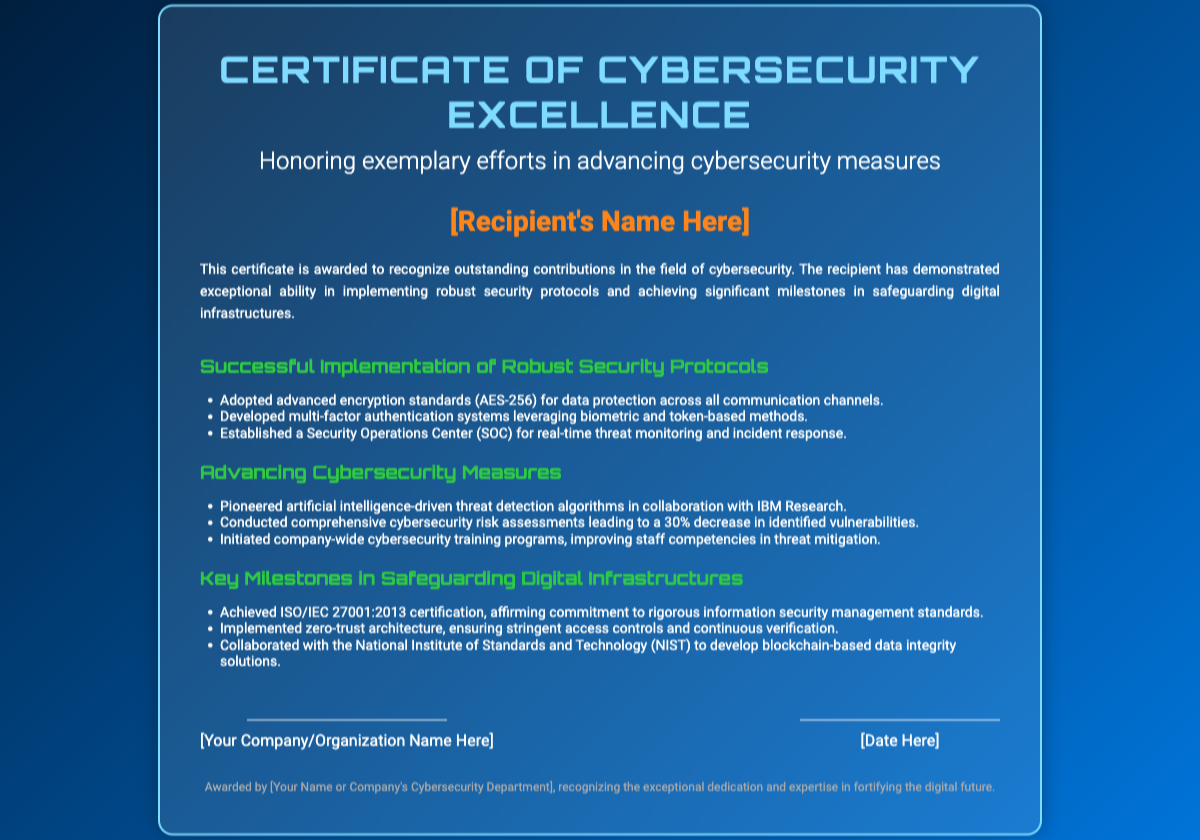What is the title of the certificate? The title of the certificate is prominently displayed at the top of the document.
Answer: Certificate of Cybersecurity Excellence Who is the recipient? The recipient's name is designated as a placeholder within the document.
Answer: [Recipient's Name Here] What advanced encryption standard is mentioned for data protection? The document specifies the encryption standard used for data protection in communication channels.
Answer: AES-256 What certification has been achieved? The document states a specific certification attained by the recipient.
Answer: ISO/IEC 27001:2013 How much has the comprehensive risk assessment decreased vulnerabilities by? The document provides a percentage reflecting the effectiveness of the risk assessment initiatives.
Answer: 30% Which organization was collaborated with for blockchain-based solutions? The name of the institution involved in developing data integrity solutions is noted in the document.
Answer: National Institute of Standards and Technology (NIST) What is the focus of the certificate? The main purpose of the certificate is outlined in the description section of the document.
Answer: Honoring exemplary efforts in advancing cybersecurity measures What is one of the roles of the Security Operations Center (SOC)? The function of the SOC is indicated as part of the achievements highlighted in the certificate.
Answer: real-time threat monitoring and incident response What type of training programs were initiated? A specific type of educational initiative is mentioned in relation to improving competencies.
Answer: company-wide cybersecurity training programs 